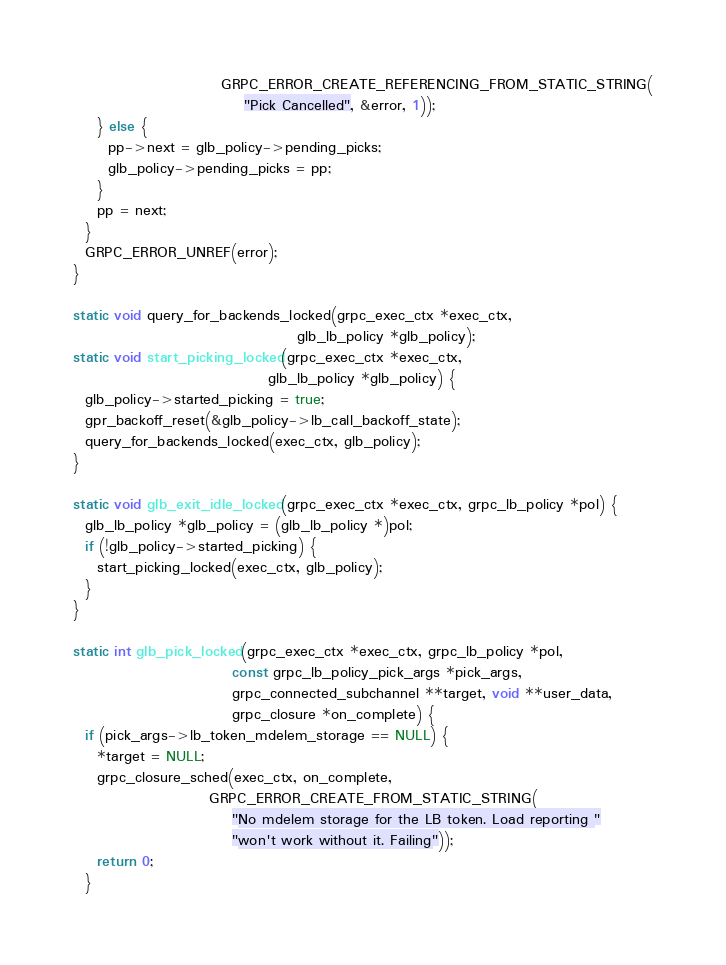Convert code to text. <code><loc_0><loc_0><loc_500><loc_500><_C_>                         GRPC_ERROR_CREATE_REFERENCING_FROM_STATIC_STRING(
                             "Pick Cancelled", &error, 1));
    } else {
      pp->next = glb_policy->pending_picks;
      glb_policy->pending_picks = pp;
    }
    pp = next;
  }
  GRPC_ERROR_UNREF(error);
}

static void query_for_backends_locked(grpc_exec_ctx *exec_ctx,
                                      glb_lb_policy *glb_policy);
static void start_picking_locked(grpc_exec_ctx *exec_ctx,
                                 glb_lb_policy *glb_policy) {
  glb_policy->started_picking = true;
  gpr_backoff_reset(&glb_policy->lb_call_backoff_state);
  query_for_backends_locked(exec_ctx, glb_policy);
}

static void glb_exit_idle_locked(grpc_exec_ctx *exec_ctx, grpc_lb_policy *pol) {
  glb_lb_policy *glb_policy = (glb_lb_policy *)pol;
  if (!glb_policy->started_picking) {
    start_picking_locked(exec_ctx, glb_policy);
  }
}

static int glb_pick_locked(grpc_exec_ctx *exec_ctx, grpc_lb_policy *pol,
                           const grpc_lb_policy_pick_args *pick_args,
                           grpc_connected_subchannel **target, void **user_data,
                           grpc_closure *on_complete) {
  if (pick_args->lb_token_mdelem_storage == NULL) {
    *target = NULL;
    grpc_closure_sched(exec_ctx, on_complete,
                       GRPC_ERROR_CREATE_FROM_STATIC_STRING(
                           "No mdelem storage for the LB token. Load reporting "
                           "won't work without it. Failing"));
    return 0;
  }
</code> 